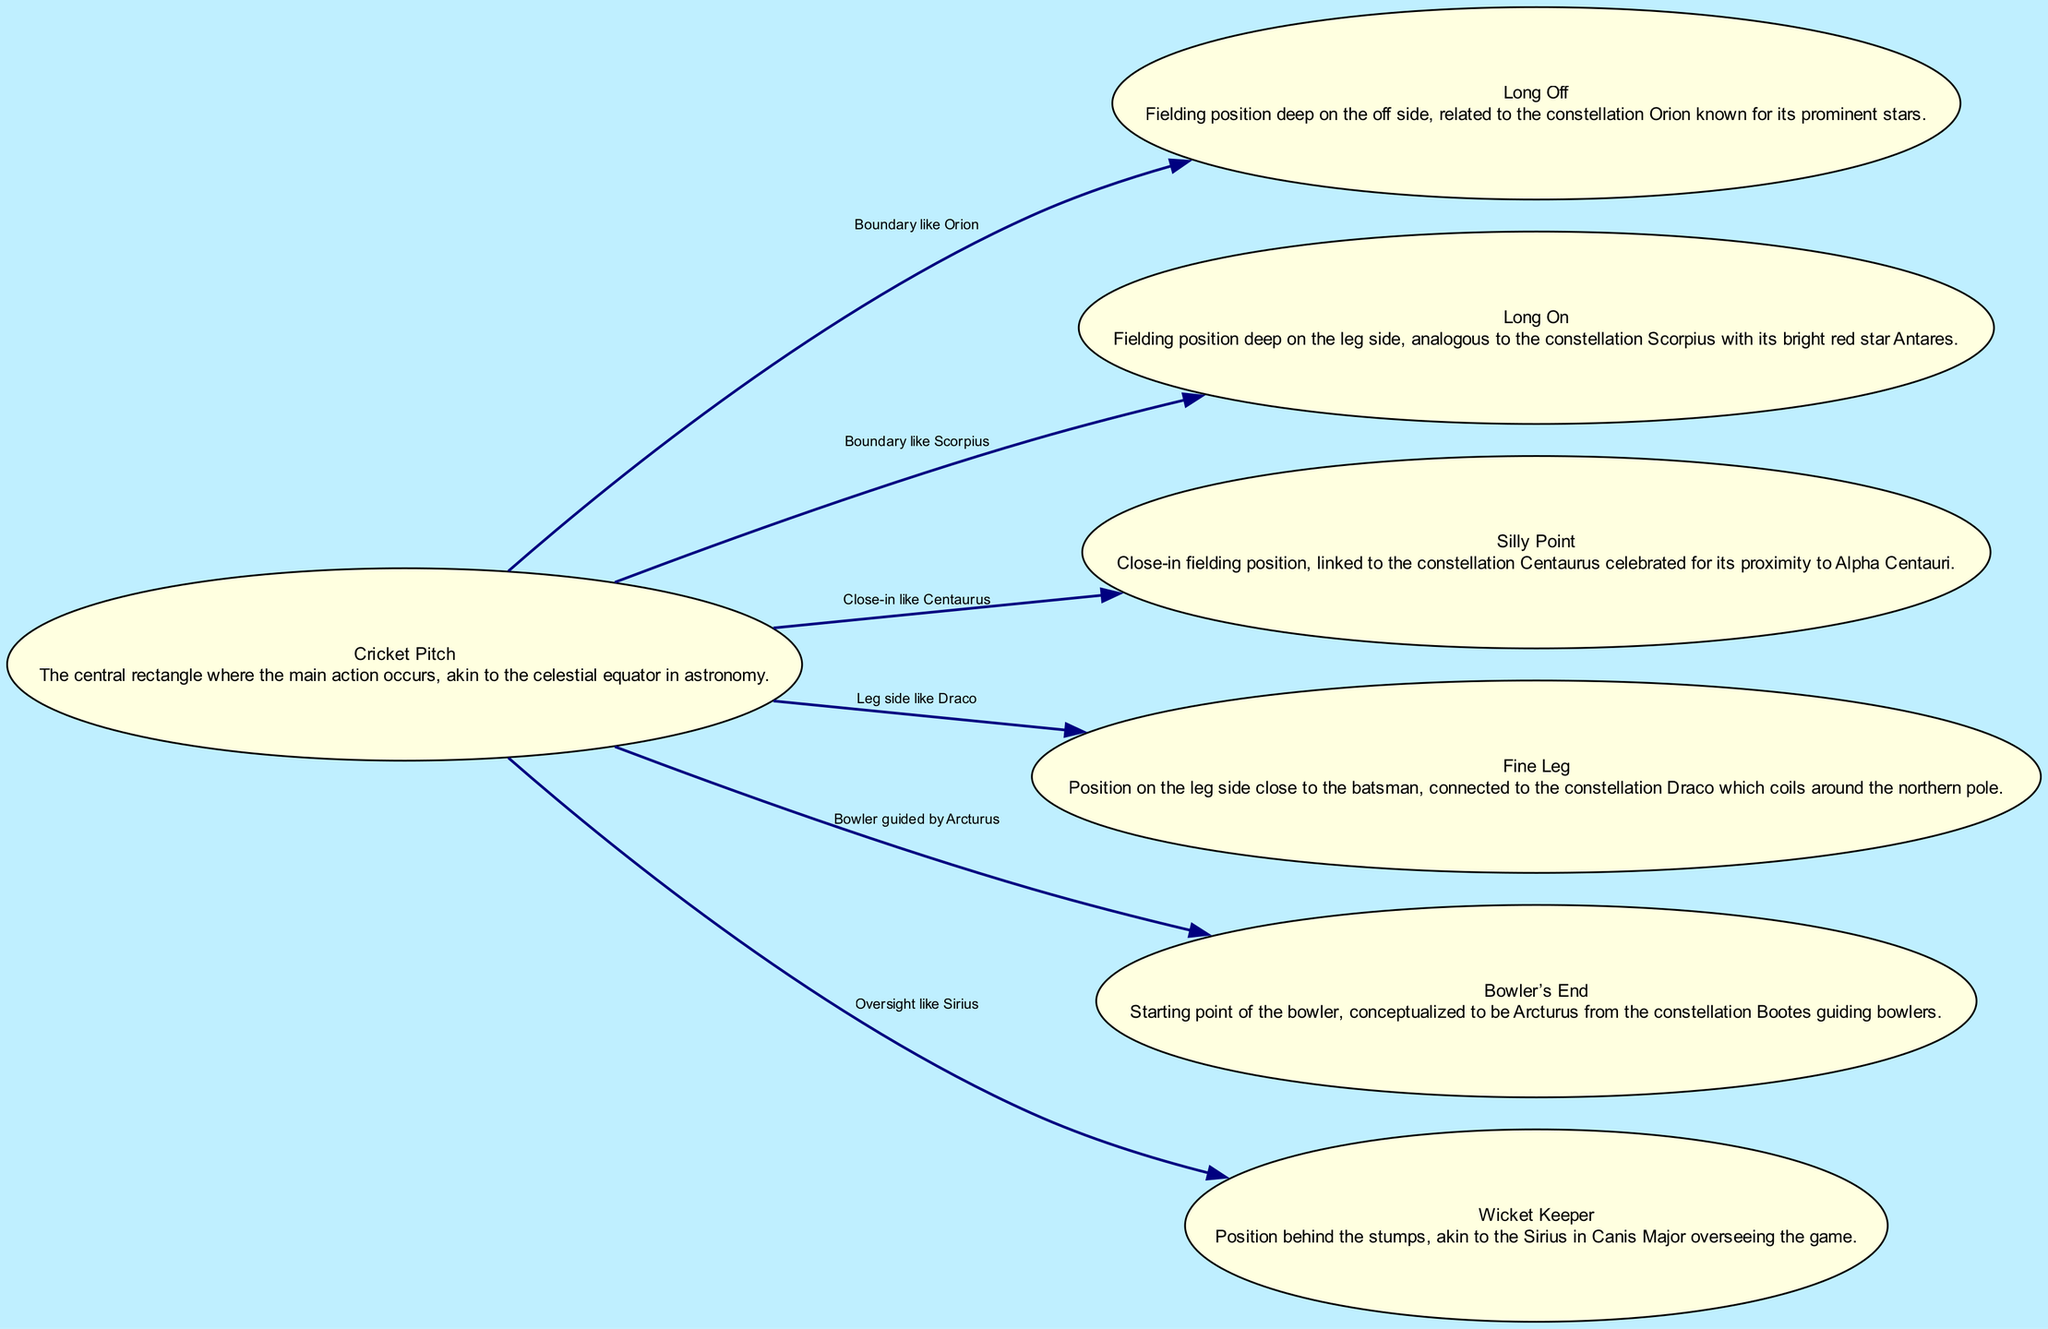What is the total number of nodes in the diagram? The diagram lists several unique positions related to cricket, each representing a node. By counting each node provided in the data (cricket pitch, long off, long on, silly point, fine leg, bowler's end, and wicket keeper), we find there are 7 nodes in total.
Answer: 7 Which constellation is associated with the long on position? The long on position is described as being analogous to the constellation Scorpius, which is known for its bright red star Antares. This information is clearly stated in the description linked to the long on node.
Answer: Scorpius What is the relationship between the cricket pitch and the wicket keeper? The wicket keeper's position is connected to the cricket pitch and is compared to Sirius in Canis Major. The edge label explicitly states this relationship, indicating that the wicket keeper oversees the game from behind the stumps, similar to how Sirius has prominence in the night sky.
Answer: Oversight like Sirius How many edges are present in the diagram? An edge defines a connection or relationship between two nodes. By reviewing the data and counting each edge listed in the 'edges' section (which describes connections from the cricket pitch to six related positions), we determine there are 6 edges in total.
Answer: 6 What position is likened to the constellation Orion? The long off fielding position is linked to the constellation Orion in the diagram. This is described in the specific relationship detailing the connection between the cricket pitch and long off, indicating that it serves as a boundary similar to the stars of Orion.
Answer: Long Off What is the relationship of the bowler's end to the constellation Bootes? The bowler's end is conceptualized in the diagram to be guided by Arcturus from the constellation Bootes. This indicates that the bowler's action at this point is comparable to the role of Arcturus in astronomy, which is a guiding star.
Answer: Bowler guided by Arcturus Which position corresponds to the constellation Draco? The fine leg position is connected to the constellation Draco, as noted in the diagram. The relationship is specified, indicating that this position on the leg side is analogous to Draco, which coils around the northern pole.
Answer: Fine Leg 